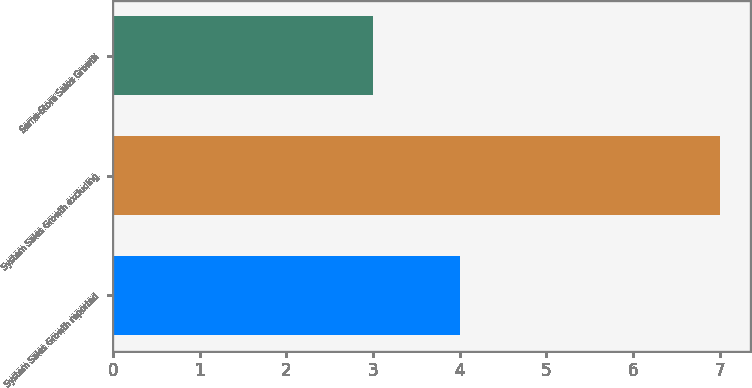Convert chart. <chart><loc_0><loc_0><loc_500><loc_500><bar_chart><fcel>System Sales Growth reported<fcel>System Sales Growth excluding<fcel>Same-Store Sales Growth<nl><fcel>4<fcel>7<fcel>3<nl></chart> 